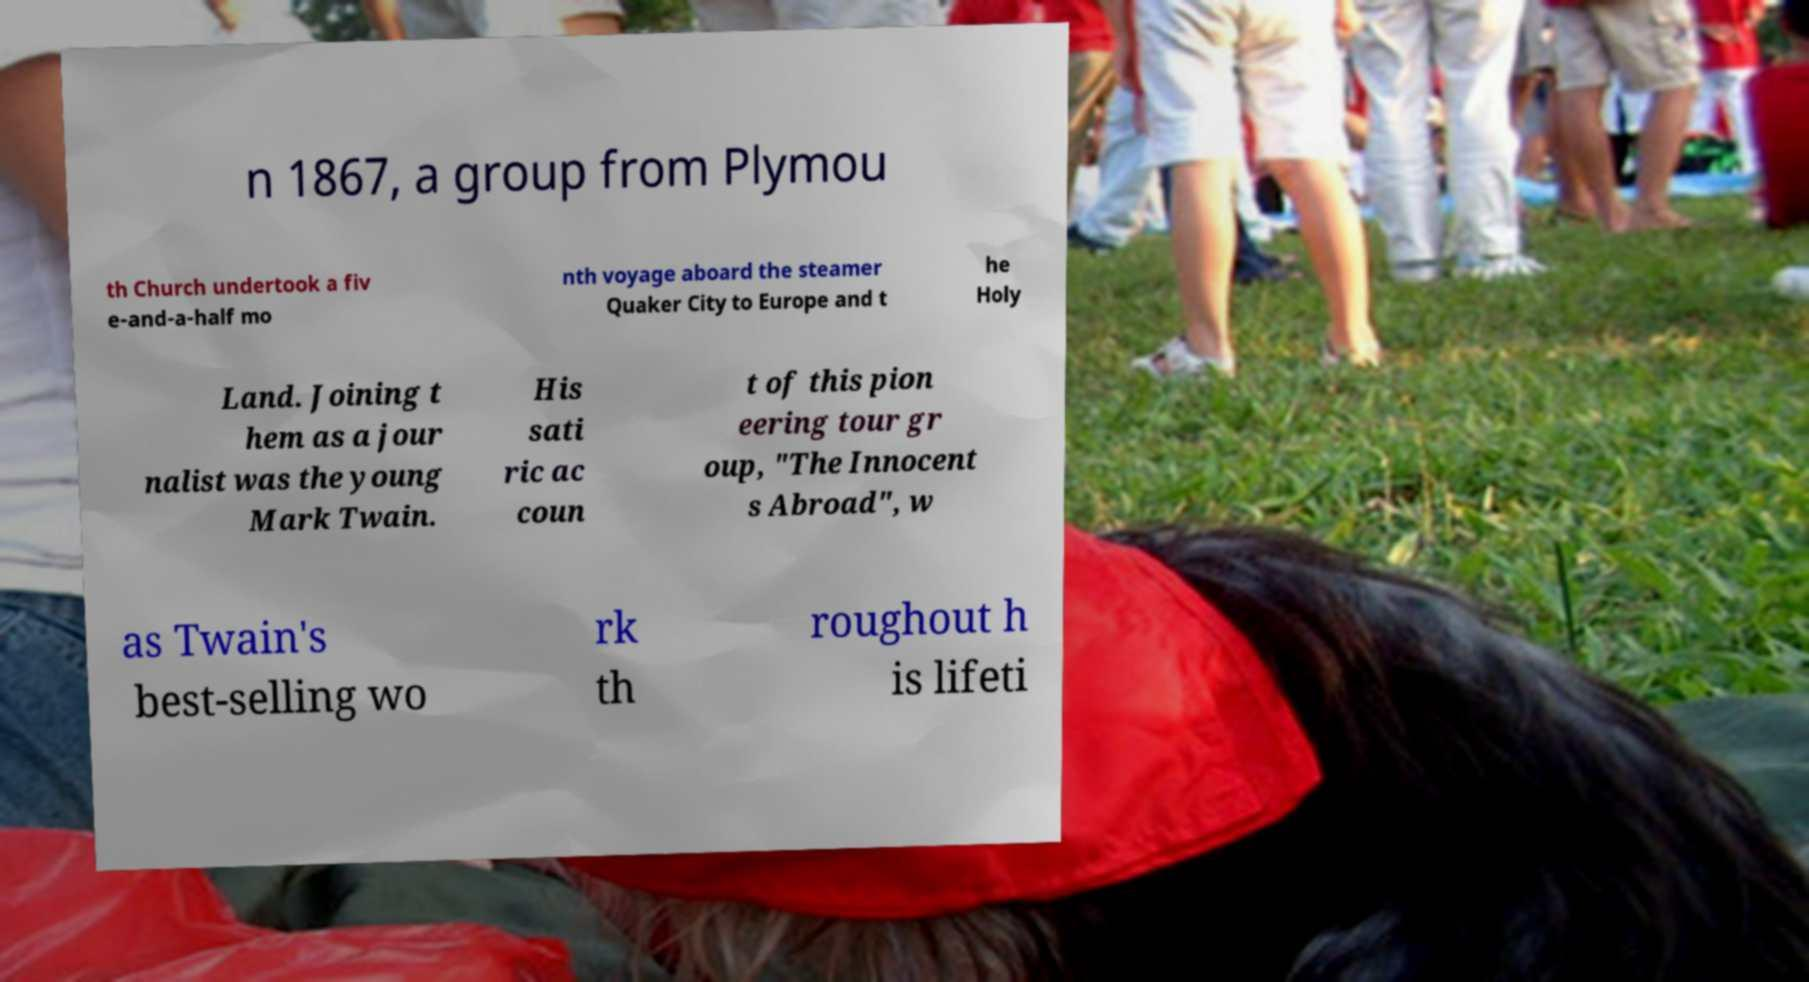Please identify and transcribe the text found in this image. n 1867, a group from Plymou th Church undertook a fiv e-and-a-half mo nth voyage aboard the steamer Quaker City to Europe and t he Holy Land. Joining t hem as a jour nalist was the young Mark Twain. His sati ric ac coun t of this pion eering tour gr oup, "The Innocent s Abroad", w as Twain's best-selling wo rk th roughout h is lifeti 